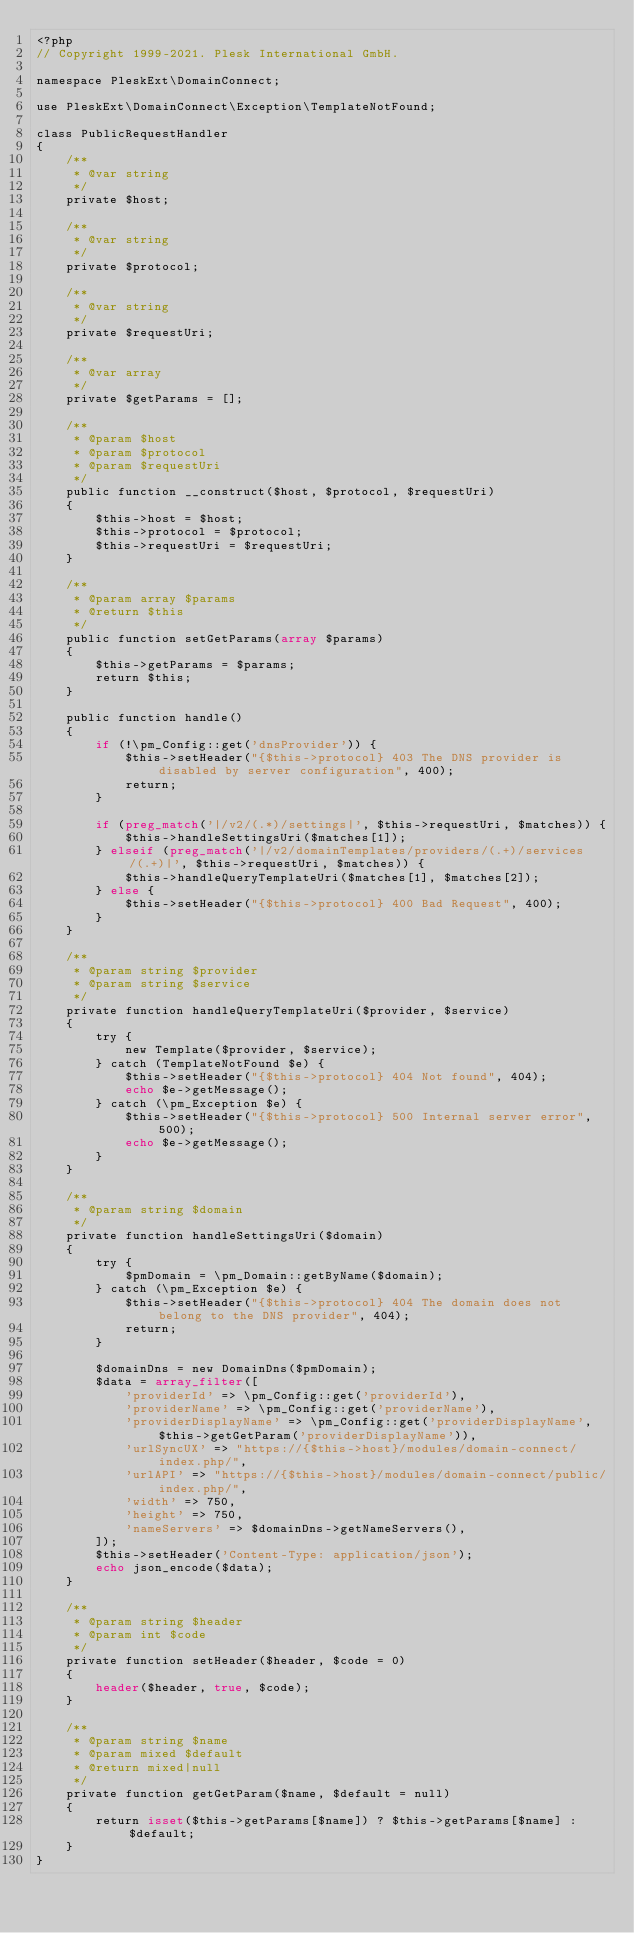<code> <loc_0><loc_0><loc_500><loc_500><_PHP_><?php
// Copyright 1999-2021. Plesk International GmbH.

namespace PleskExt\DomainConnect;

use PleskExt\DomainConnect\Exception\TemplateNotFound;

class PublicRequestHandler
{
    /**
     * @var string
     */
    private $host;

    /**
     * @var string
     */
    private $protocol;

    /**
     * @var string
     */
    private $requestUri;

    /**
     * @var array
     */
    private $getParams = [];

    /**
     * @param $host
     * @param $protocol
     * @param $requestUri
     */
    public function __construct($host, $protocol, $requestUri)
    {
        $this->host = $host;
        $this->protocol = $protocol;
        $this->requestUri = $requestUri;
    }

    /**
     * @param array $params
     * @return $this
     */
    public function setGetParams(array $params)
    {
        $this->getParams = $params;
        return $this;
    }

    public function handle()
    {
        if (!\pm_Config::get('dnsProvider')) {
            $this->setHeader("{$this->protocol} 403 The DNS provider is disabled by server configuration", 400);
            return;
        }

        if (preg_match('|/v2/(.*)/settings|', $this->requestUri, $matches)) {
            $this->handleSettingsUri($matches[1]);
        } elseif (preg_match('|/v2/domainTemplates/providers/(.+)/services/(.+)|', $this->requestUri, $matches)) {
            $this->handleQueryTemplateUri($matches[1], $matches[2]);
        } else {
            $this->setHeader("{$this->protocol} 400 Bad Request", 400);
        }
    }

    /**
     * @param string $provider
     * @param string $service
     */
    private function handleQueryTemplateUri($provider, $service)
    {
        try {
            new Template($provider, $service);
        } catch (TemplateNotFound $e) {
            $this->setHeader("{$this->protocol} 404 Not found", 404);
            echo $e->getMessage();
        } catch (\pm_Exception $e) {
            $this->setHeader("{$this->protocol} 500 Internal server error", 500);
            echo $e->getMessage();
        }
    }

    /**
     * @param string $domain
     */
    private function handleSettingsUri($domain)
    {
        try {
            $pmDomain = \pm_Domain::getByName($domain);
        } catch (\pm_Exception $e) {
            $this->setHeader("{$this->protocol} 404 The domain does not belong to the DNS provider", 404);
            return;
        }

        $domainDns = new DomainDns($pmDomain);
        $data = array_filter([
            'providerId' => \pm_Config::get('providerId'),
            'providerName' => \pm_Config::get('providerName'),
            'providerDisplayName' => \pm_Config::get('providerDisplayName', $this->getGetParam('providerDisplayName')),
            'urlSyncUX' => "https://{$this->host}/modules/domain-connect/index.php/",
            'urlAPI' => "https://{$this->host}/modules/domain-connect/public/index.php/",
            'width' => 750,
            'height' => 750,
            'nameServers' => $domainDns->getNameServers(),
        ]);
        $this->setHeader('Content-Type: application/json');
        echo json_encode($data);
    }

    /**
     * @param string $header
     * @param int $code
     */
    private function setHeader($header, $code = 0)
    {
        header($header, true, $code);
    }

    /**
     * @param string $name
     * @param mixed $default
     * @return mixed|null
     */
    private function getGetParam($name, $default = null)
    {
        return isset($this->getParams[$name]) ? $this->getParams[$name] : $default;
    }
}
</code> 